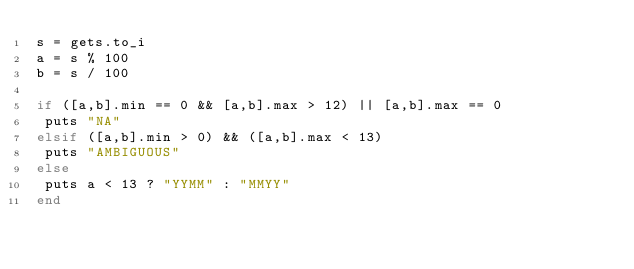<code> <loc_0><loc_0><loc_500><loc_500><_Ruby_>s = gets.to_i
a = s % 100
b = s / 100

if ([a,b].min == 0 && [a,b].max > 12) || [a,b].max == 0
 puts "NA"
elsif ([a,b].min > 0) && ([a,b].max < 13)
 puts "AMBIGUOUS"
else
 puts a < 13 ? "YYMM" : "MMYY"
end
</code> 